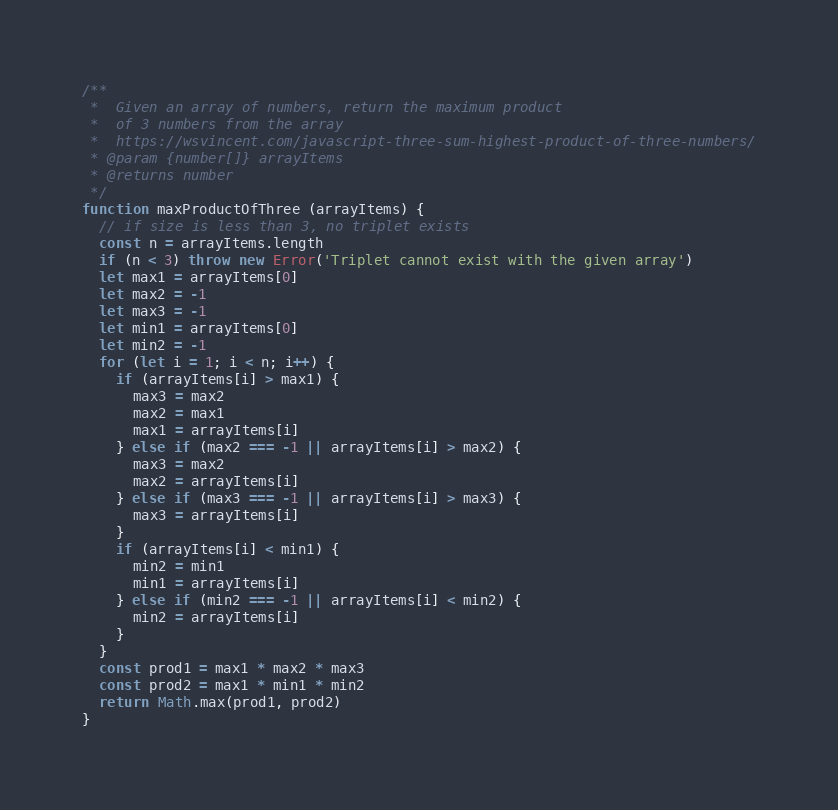<code> <loc_0><loc_0><loc_500><loc_500><_JavaScript_>/**
 *  Given an array of numbers, return the maximum product
 *  of 3 numbers from the array
 *  https://wsvincent.com/javascript-three-sum-highest-product-of-three-numbers/
 * @param {number[]} arrayItems
 * @returns number
 */
function maxProductOfThree (arrayItems) {
  // if size is less than 3, no triplet exists
  const n = arrayItems.length
  if (n < 3) throw new Error('Triplet cannot exist with the given array')
  let max1 = arrayItems[0]
  let max2 = -1
  let max3 = -1
  let min1 = arrayItems[0]
  let min2 = -1
  for (let i = 1; i < n; i++) {
    if (arrayItems[i] > max1) {
      max3 = max2
      max2 = max1
      max1 = arrayItems[i]
    } else if (max2 === -1 || arrayItems[i] > max2) {
      max3 = max2
      max2 = arrayItems[i]
    } else if (max3 === -1 || arrayItems[i] > max3) {
      max3 = arrayItems[i]
    }
    if (arrayItems[i] < min1) {
      min2 = min1
      min1 = arrayItems[i]
    } else if (min2 === -1 || arrayItems[i] < min2) {
      min2 = arrayItems[i]
    }
  }
  const prod1 = max1 * max2 * max3
  const prod2 = max1 * min1 * min2
  return Math.max(prod1, prod2)
}
</code> 